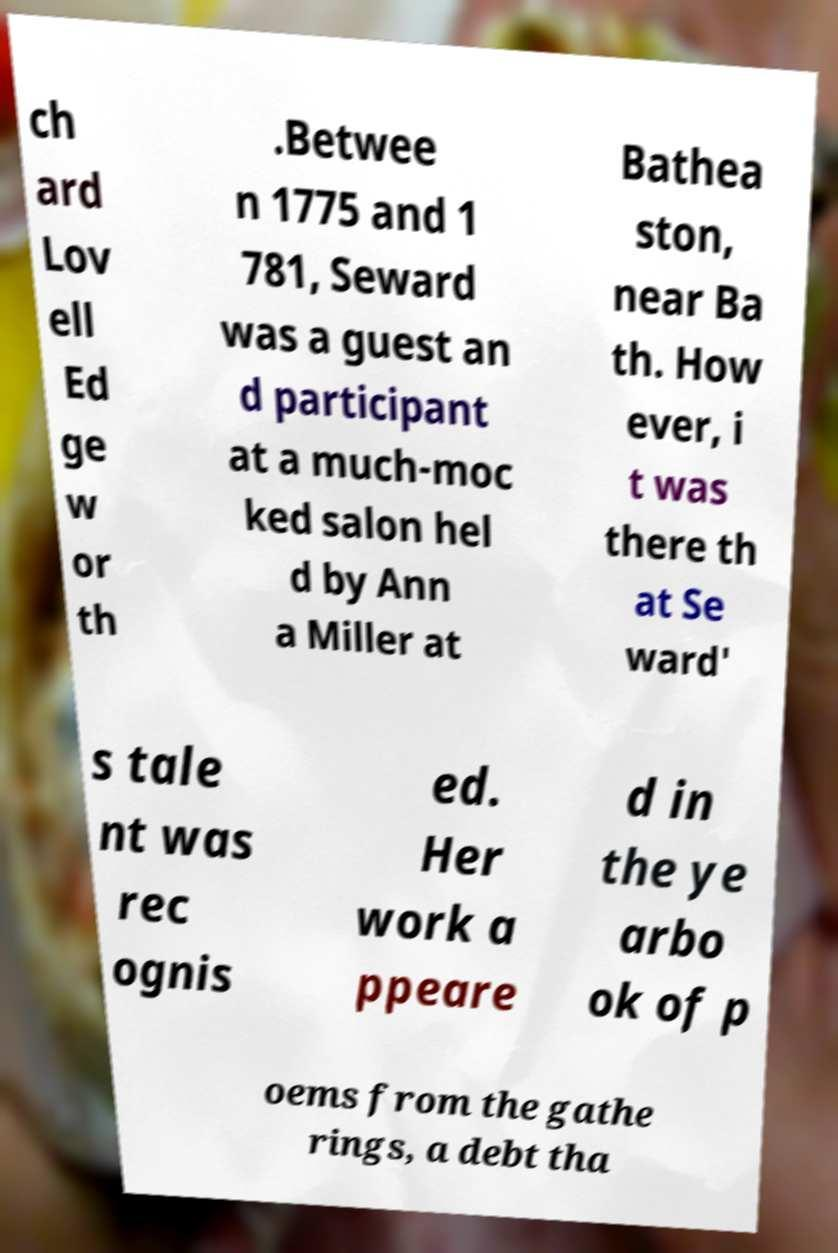What messages or text are displayed in this image? I need them in a readable, typed format. ch ard Lov ell Ed ge w or th .Betwee n 1775 and 1 781, Seward was a guest an d participant at a much-moc ked salon hel d by Ann a Miller at Bathea ston, near Ba th. How ever, i t was there th at Se ward' s tale nt was rec ognis ed. Her work a ppeare d in the ye arbo ok of p oems from the gathe rings, a debt tha 